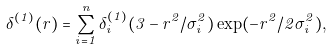Convert formula to latex. <formula><loc_0><loc_0><loc_500><loc_500>\delta ^ { ( 1 ) } ( r ) = \sum _ { i = 1 } ^ { n } \delta _ { i } ^ { ( 1 ) } ( 3 - r ^ { 2 } / \sigma _ { i } ^ { 2 } ) \exp ( - r ^ { 2 } / 2 \sigma _ { i } ^ { 2 } ) ,</formula> 